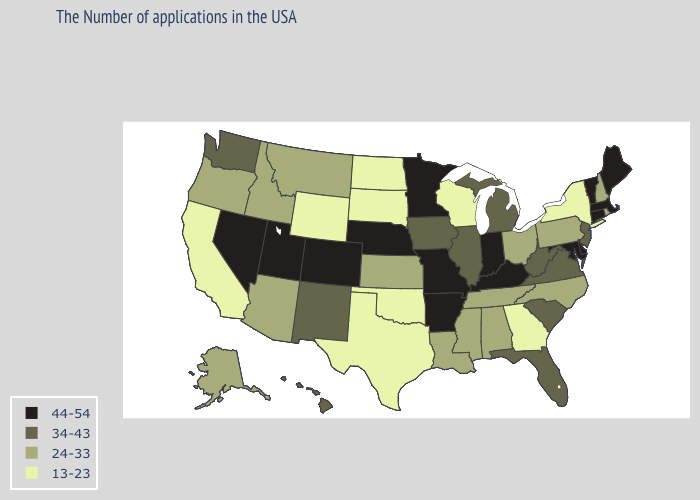What is the lowest value in states that border Georgia?
Keep it brief. 24-33. Does North Dakota have the same value as Utah?
Give a very brief answer. No. What is the value of South Dakota?
Write a very short answer. 13-23. Does New Mexico have a higher value than Massachusetts?
Short answer required. No. Name the states that have a value in the range 44-54?
Keep it brief. Maine, Massachusetts, Vermont, Connecticut, Delaware, Maryland, Kentucky, Indiana, Missouri, Arkansas, Minnesota, Nebraska, Colorado, Utah, Nevada. What is the lowest value in the MidWest?
Short answer required. 13-23. Does the map have missing data?
Quick response, please. No. What is the value of Alaska?
Concise answer only. 24-33. Name the states that have a value in the range 44-54?
Write a very short answer. Maine, Massachusetts, Vermont, Connecticut, Delaware, Maryland, Kentucky, Indiana, Missouri, Arkansas, Minnesota, Nebraska, Colorado, Utah, Nevada. Name the states that have a value in the range 44-54?
Keep it brief. Maine, Massachusetts, Vermont, Connecticut, Delaware, Maryland, Kentucky, Indiana, Missouri, Arkansas, Minnesota, Nebraska, Colorado, Utah, Nevada. What is the highest value in the South ?
Give a very brief answer. 44-54. Name the states that have a value in the range 13-23?
Give a very brief answer. New York, Georgia, Wisconsin, Oklahoma, Texas, South Dakota, North Dakota, Wyoming, California. Name the states that have a value in the range 34-43?
Concise answer only. New Jersey, Virginia, South Carolina, West Virginia, Florida, Michigan, Illinois, Iowa, New Mexico, Washington, Hawaii. Name the states that have a value in the range 34-43?
Quick response, please. New Jersey, Virginia, South Carolina, West Virginia, Florida, Michigan, Illinois, Iowa, New Mexico, Washington, Hawaii. Name the states that have a value in the range 34-43?
Be succinct. New Jersey, Virginia, South Carolina, West Virginia, Florida, Michigan, Illinois, Iowa, New Mexico, Washington, Hawaii. 